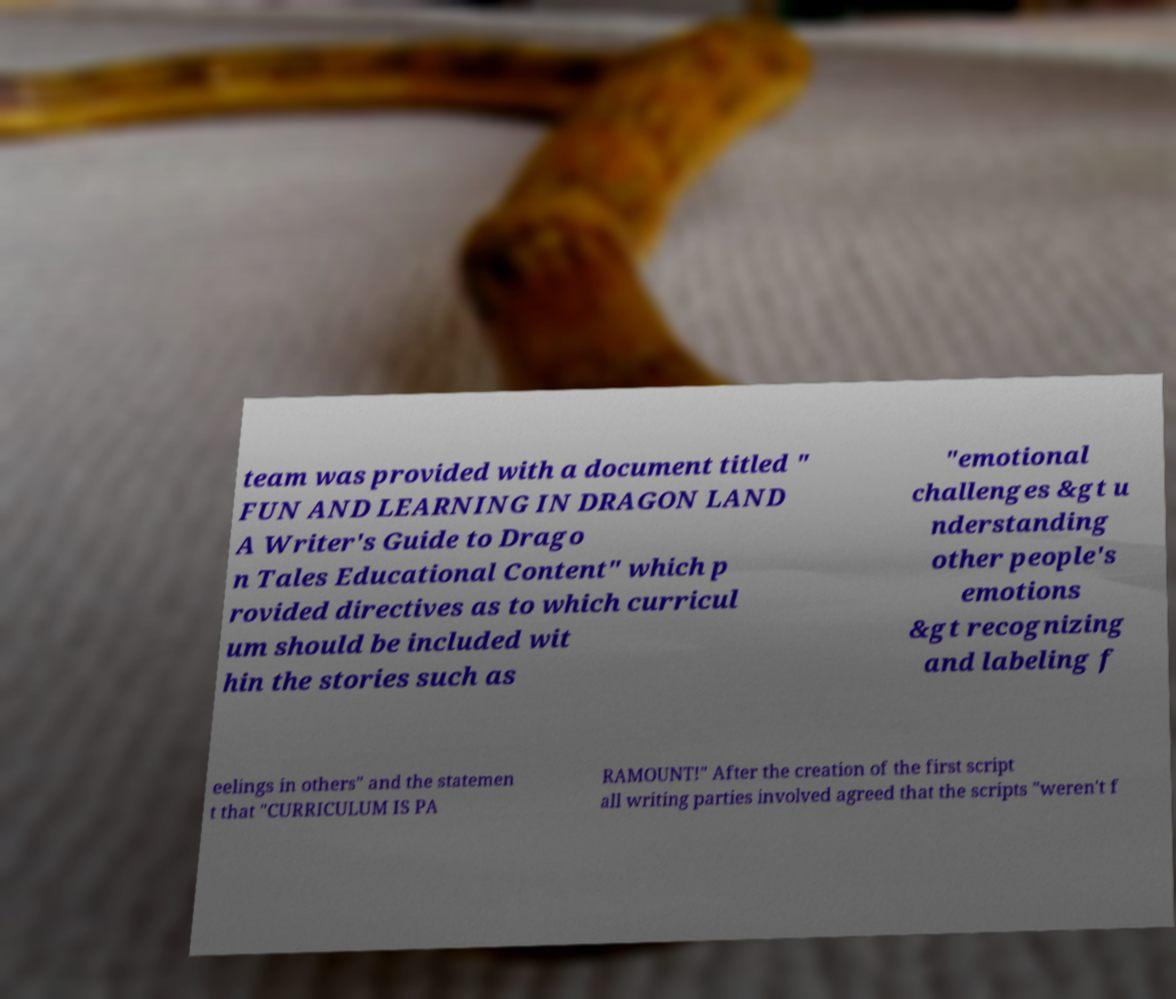I need the written content from this picture converted into text. Can you do that? team was provided with a document titled " FUN AND LEARNING IN DRAGON LAND A Writer's Guide to Drago n Tales Educational Content" which p rovided directives as to which curricul um should be included wit hin the stories such as "emotional challenges &gt u nderstanding other people's emotions &gt recognizing and labeling f eelings in others" and the statemen t that "CURRICULUM IS PA RAMOUNT!" After the creation of the first script all writing parties involved agreed that the scripts "weren't f 